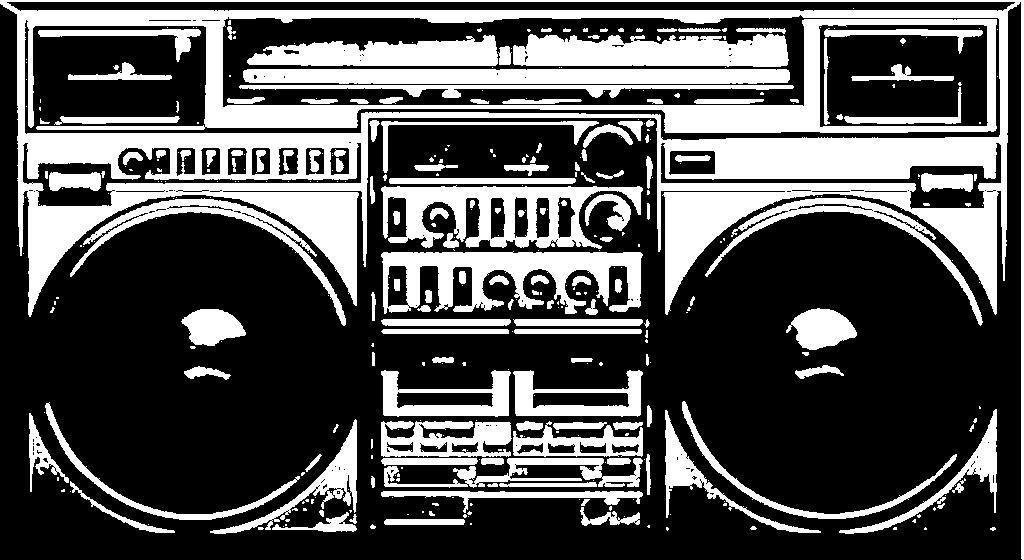What is the color scheme of the image? The image is black and white. What object can be seen in the image? There is a radio in the image. How many elbows can be seen in the image? There are no elbows visible in the image, as it is a black and white image featuring a radio. Is there an army present in the image? There is no army depicted in the image; it only features a radio. 